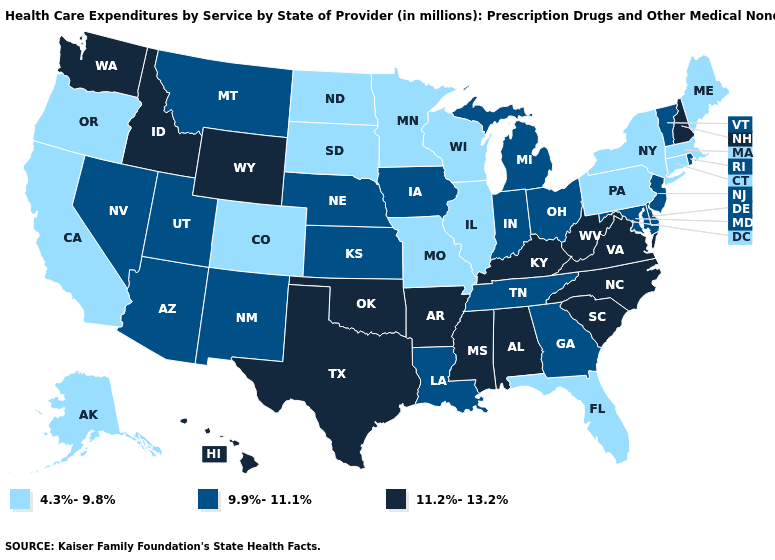How many symbols are there in the legend?
Be succinct. 3. What is the value of Washington?
Quick response, please. 11.2%-13.2%. Which states have the highest value in the USA?
Answer briefly. Alabama, Arkansas, Hawaii, Idaho, Kentucky, Mississippi, New Hampshire, North Carolina, Oklahoma, South Carolina, Texas, Virginia, Washington, West Virginia, Wyoming. Does New Mexico have the lowest value in the West?
Quick response, please. No. What is the highest value in the West ?
Answer briefly. 11.2%-13.2%. Among the states that border Nevada , which have the highest value?
Write a very short answer. Idaho. What is the highest value in the USA?
Short answer required. 11.2%-13.2%. Does Kansas have the highest value in the MidWest?
Keep it brief. Yes. Does Iowa have the same value as Georgia?
Short answer required. Yes. What is the value of Alabama?
Short answer required. 11.2%-13.2%. Does the first symbol in the legend represent the smallest category?
Keep it brief. Yes. Name the states that have a value in the range 4.3%-9.8%?
Keep it brief. Alaska, California, Colorado, Connecticut, Florida, Illinois, Maine, Massachusetts, Minnesota, Missouri, New York, North Dakota, Oregon, Pennsylvania, South Dakota, Wisconsin. What is the lowest value in the USA?
Concise answer only. 4.3%-9.8%. What is the value of Montana?
Short answer required. 9.9%-11.1%. 